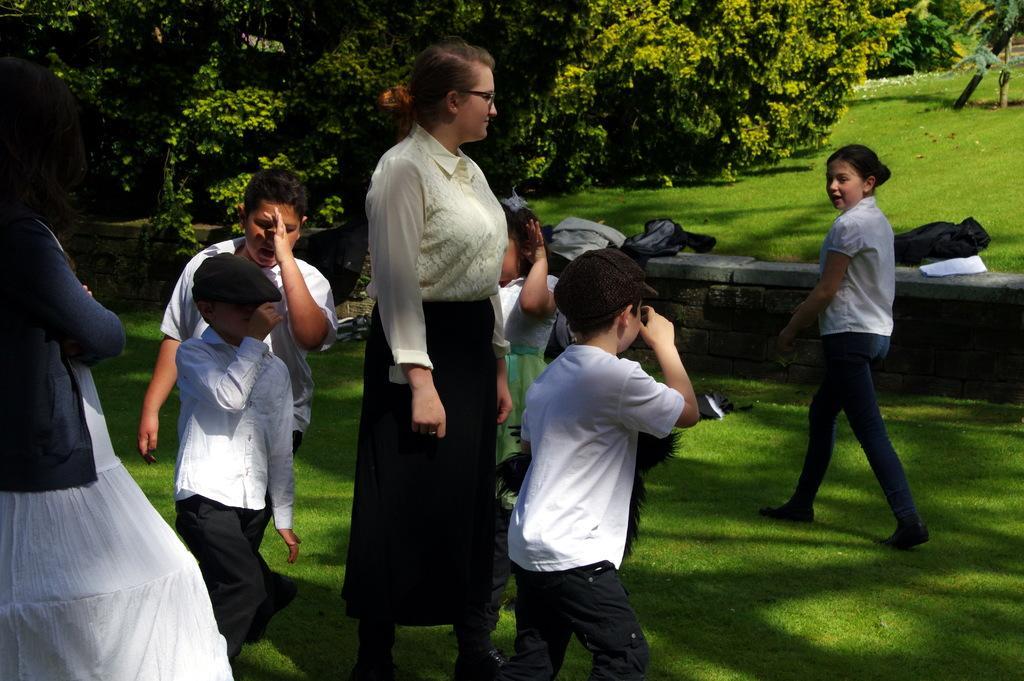Can you describe this image briefly? In the center of the image we can see a lady standing. She is wearing glasses and there are kids. On the left there is a girl. In the background there are trees and we can see bags placed on the grass. 